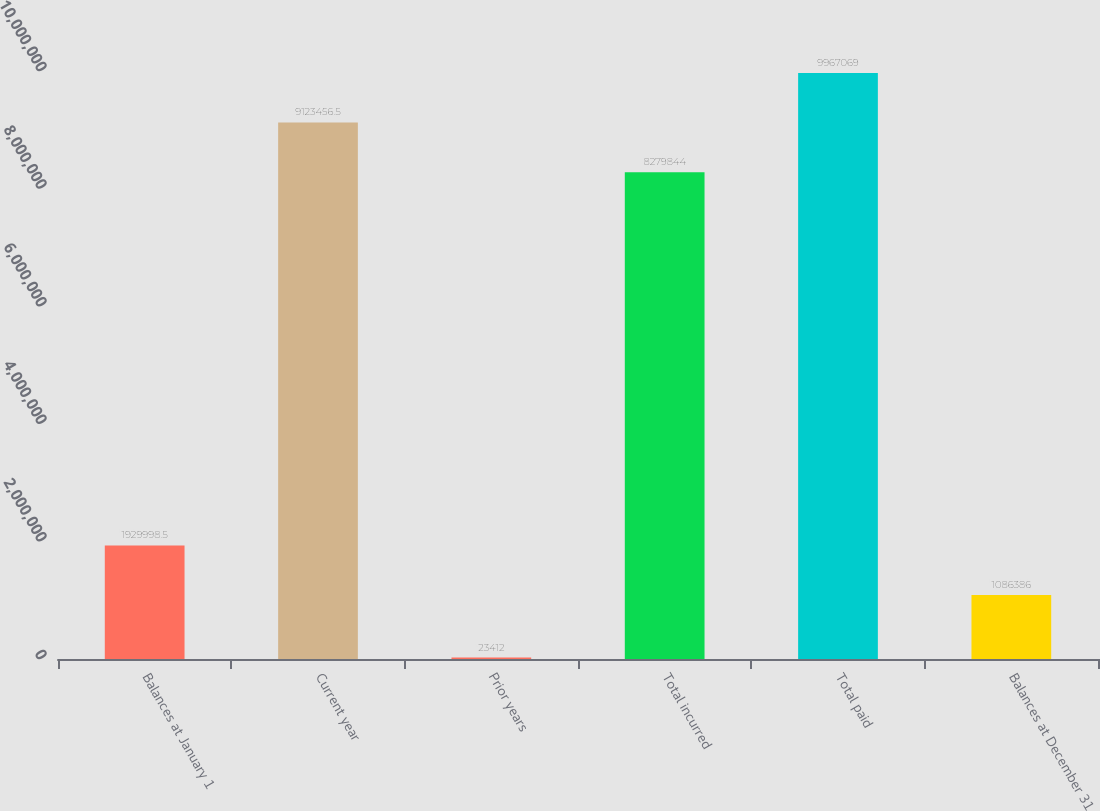<chart> <loc_0><loc_0><loc_500><loc_500><bar_chart><fcel>Balances at January 1<fcel>Current year<fcel>Prior years<fcel>Total incurred<fcel>Total paid<fcel>Balances at December 31<nl><fcel>1.93e+06<fcel>9.12346e+06<fcel>23412<fcel>8.27984e+06<fcel>9.96707e+06<fcel>1.08639e+06<nl></chart> 